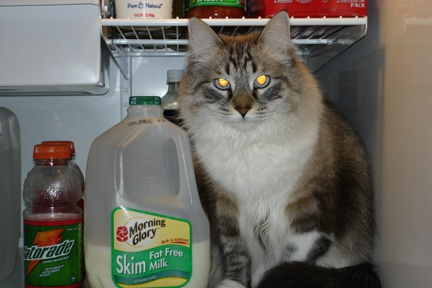Describe the objects in this image and their specific colors. I can see cat in darkgray, gray, and black tones and bottle in darkgray, black, maroon, and gray tones in this image. 